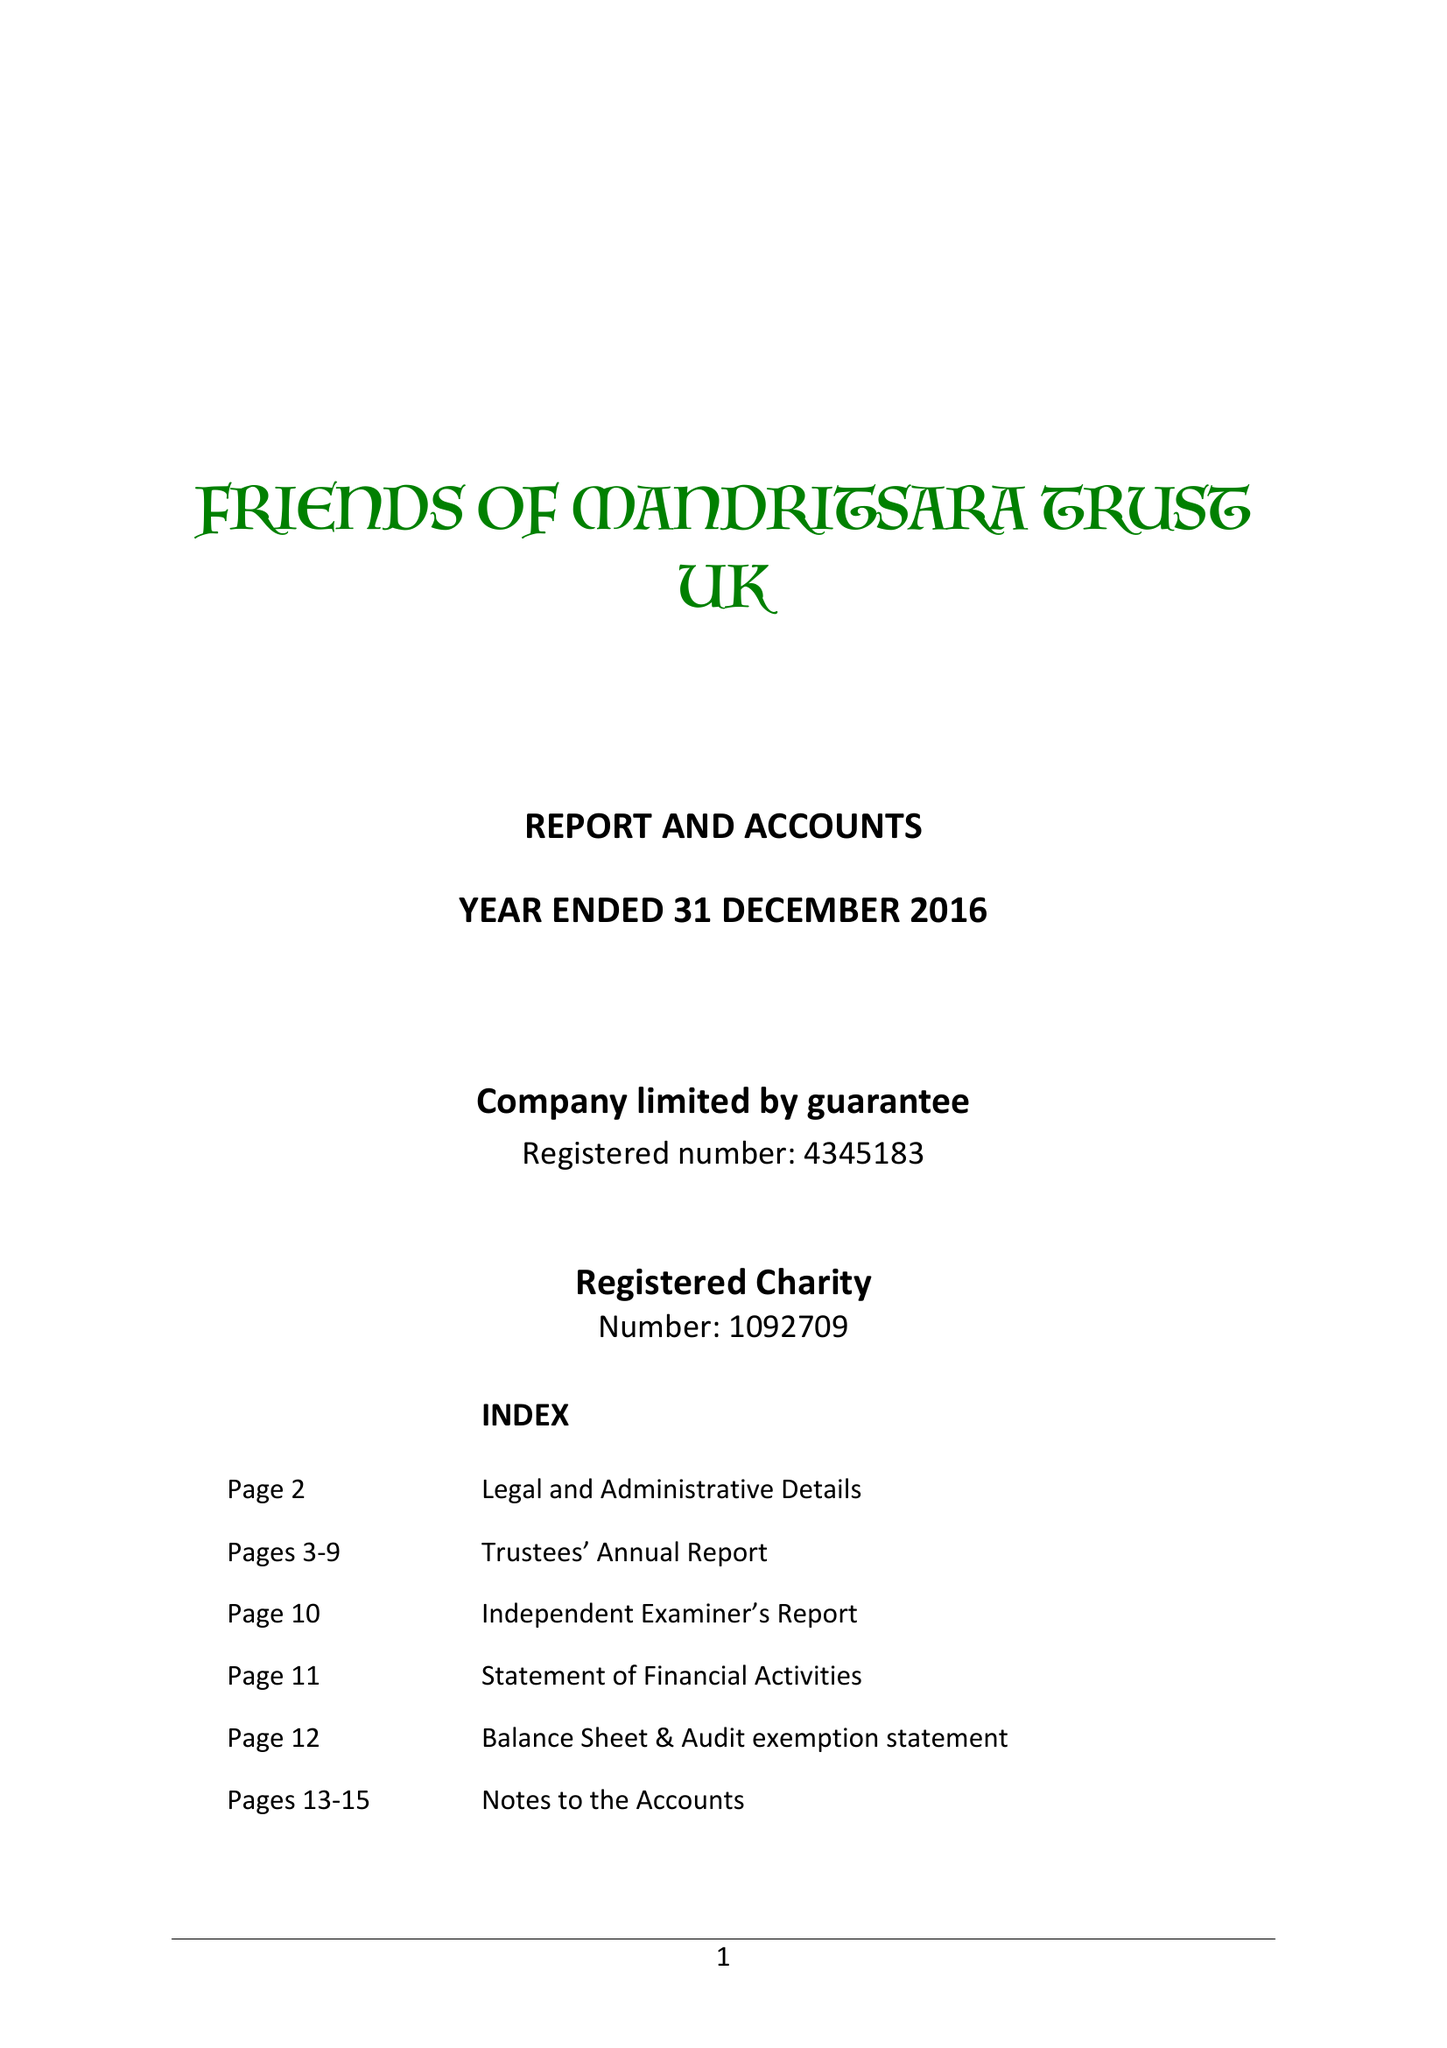What is the value for the address__street_line?
Answer the question using a single word or phrase. 29 PRIORY ROAD 